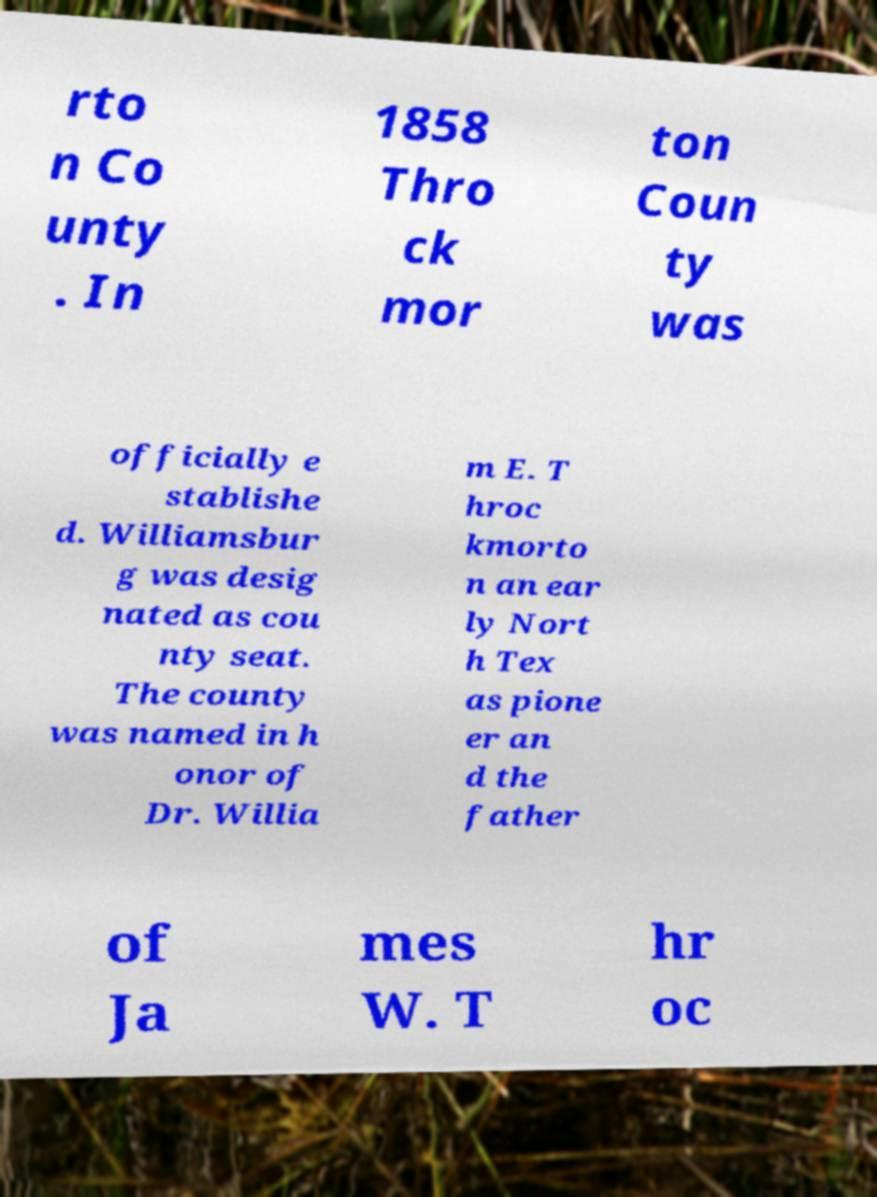Can you read and provide the text displayed in the image?This photo seems to have some interesting text. Can you extract and type it out for me? rto n Co unty . In 1858 Thro ck mor ton Coun ty was officially e stablishe d. Williamsbur g was desig nated as cou nty seat. The county was named in h onor of Dr. Willia m E. T hroc kmorto n an ear ly Nort h Tex as pione er an d the father of Ja mes W. T hr oc 